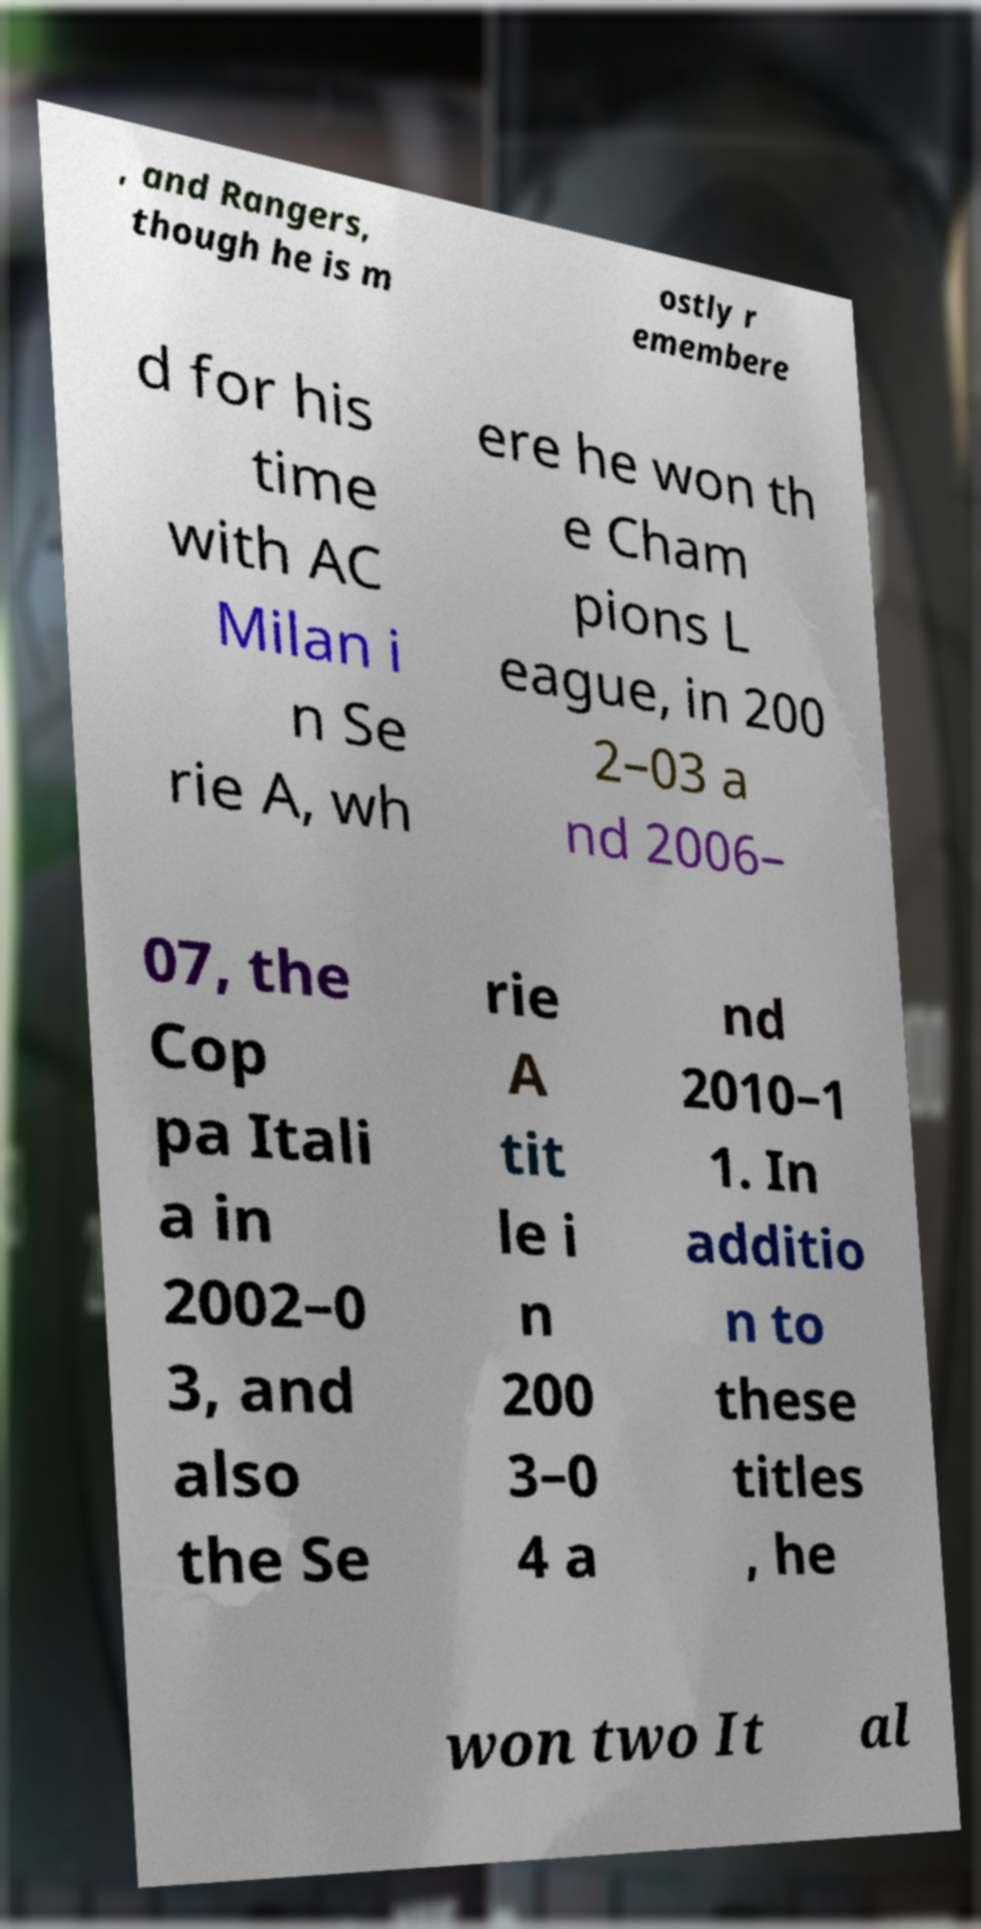Please identify and transcribe the text found in this image. , and Rangers, though he is m ostly r emembere d for his time with AC Milan i n Se rie A, wh ere he won th e Cham pions L eague, in 200 2–03 a nd 2006– 07, the Cop pa Itali a in 2002–0 3, and also the Se rie A tit le i n 200 3–0 4 a nd 2010–1 1. In additio n to these titles , he won two It al 